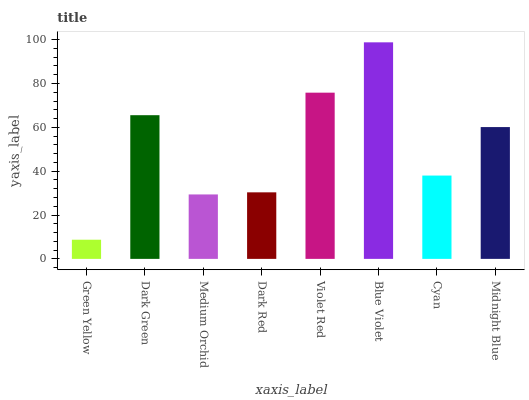Is Dark Green the minimum?
Answer yes or no. No. Is Dark Green the maximum?
Answer yes or no. No. Is Dark Green greater than Green Yellow?
Answer yes or no. Yes. Is Green Yellow less than Dark Green?
Answer yes or no. Yes. Is Green Yellow greater than Dark Green?
Answer yes or no. No. Is Dark Green less than Green Yellow?
Answer yes or no. No. Is Midnight Blue the high median?
Answer yes or no. Yes. Is Cyan the low median?
Answer yes or no. Yes. Is Violet Red the high median?
Answer yes or no. No. Is Dark Green the low median?
Answer yes or no. No. 